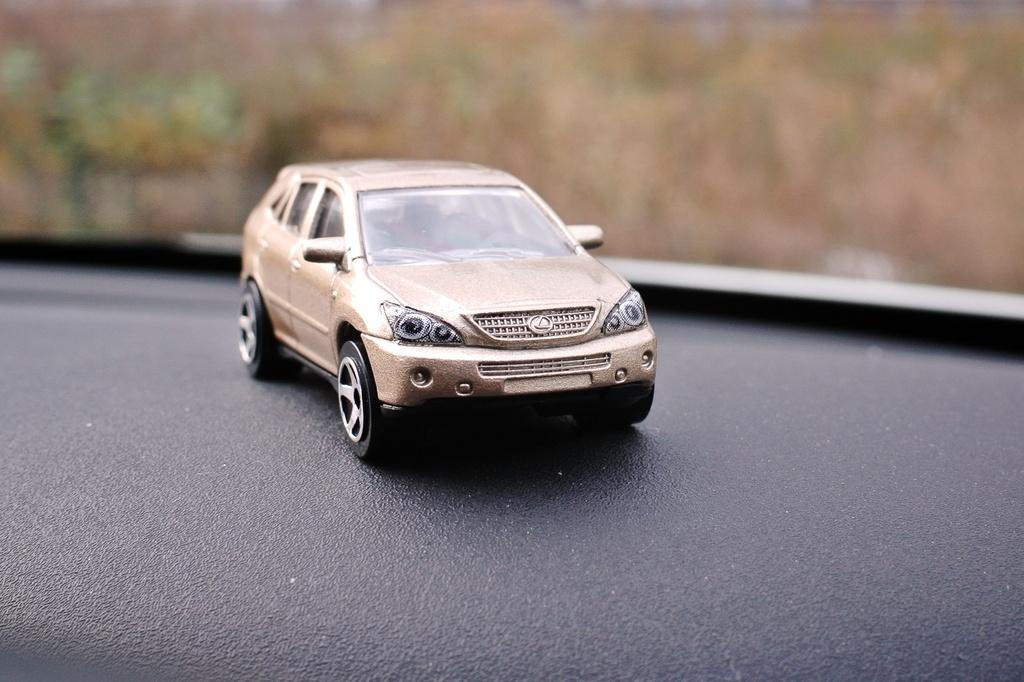What is the main object in the image? There is a toy car in the image. What color is the surface on which the toy car is placed? The toy car is on a black color surface. Can you describe the background of the image? The background of the image is blurred. What type of soap is being used to clean the toy car in the image? There is no soap or cleaning activity depicted in the image; it only shows a toy car on a black surface with a blurred background. 